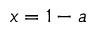<formula> <loc_0><loc_0><loc_500><loc_500>x = 1 - a</formula> 